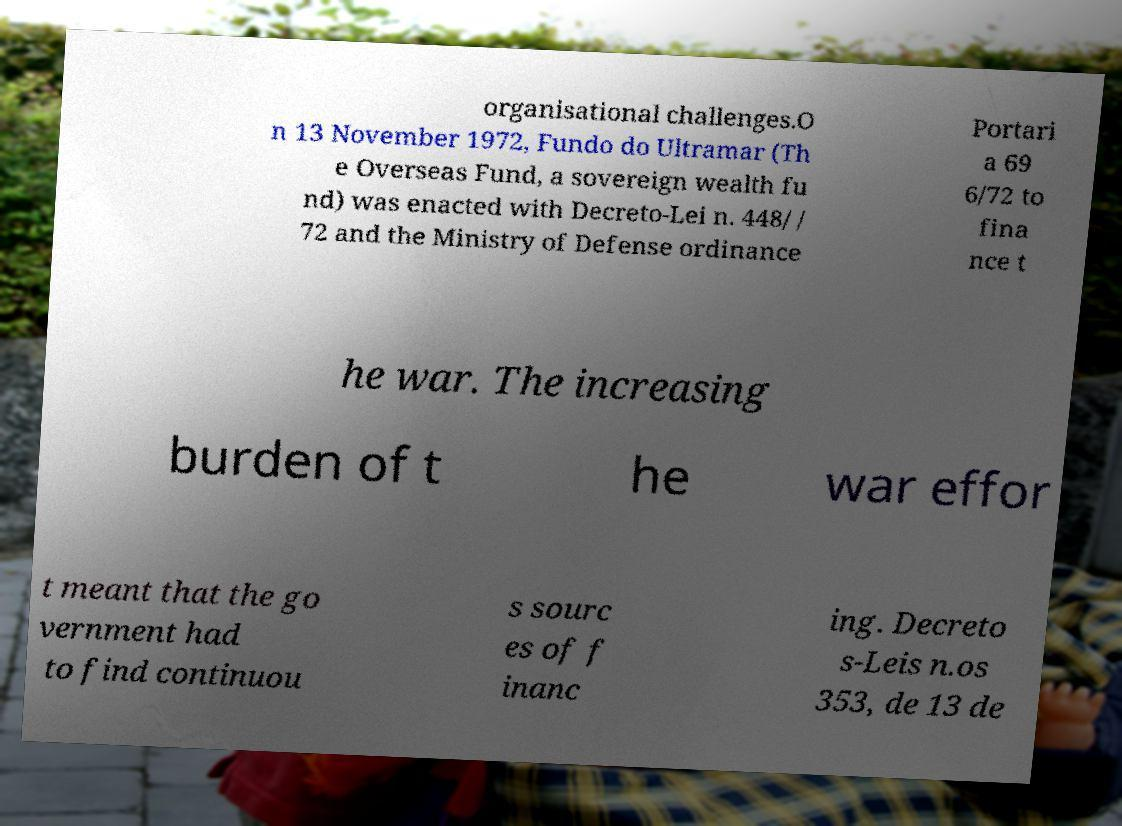Could you extract and type out the text from this image? organisational challenges.O n 13 November 1972, Fundo do Ultramar (Th e Overseas Fund, a sovereign wealth fu nd) was enacted with Decreto-Lei n. 448/ / 72 and the Ministry of Defense ordinance Portari a 69 6/72 to fina nce t he war. The increasing burden of t he war effor t meant that the go vernment had to find continuou s sourc es of f inanc ing. Decreto s-Leis n.os 353, de 13 de 